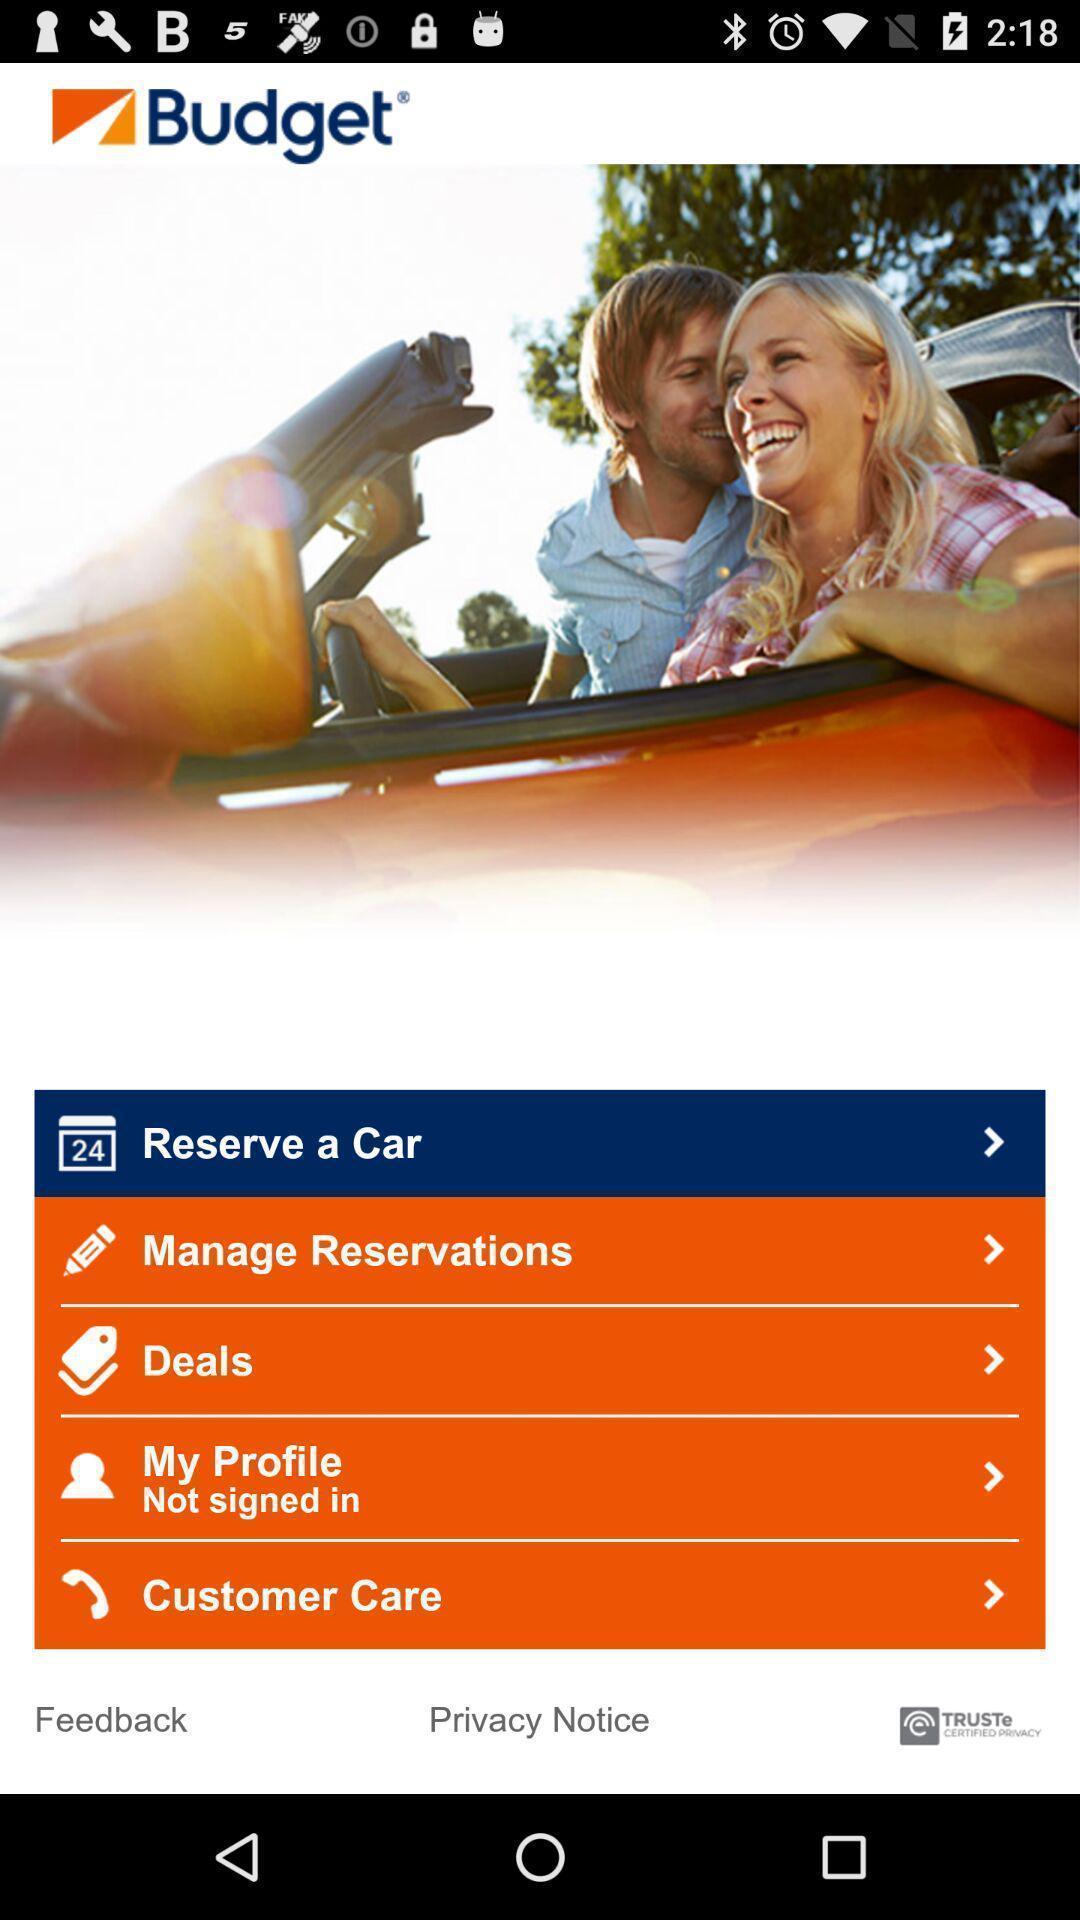Tell me about the visual elements in this screen capture. Screen displaying multiple service options in an e-hailing application. 